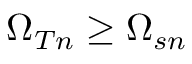<formula> <loc_0><loc_0><loc_500><loc_500>\Omega _ { T n } \geq \Omega _ { s n }</formula> 